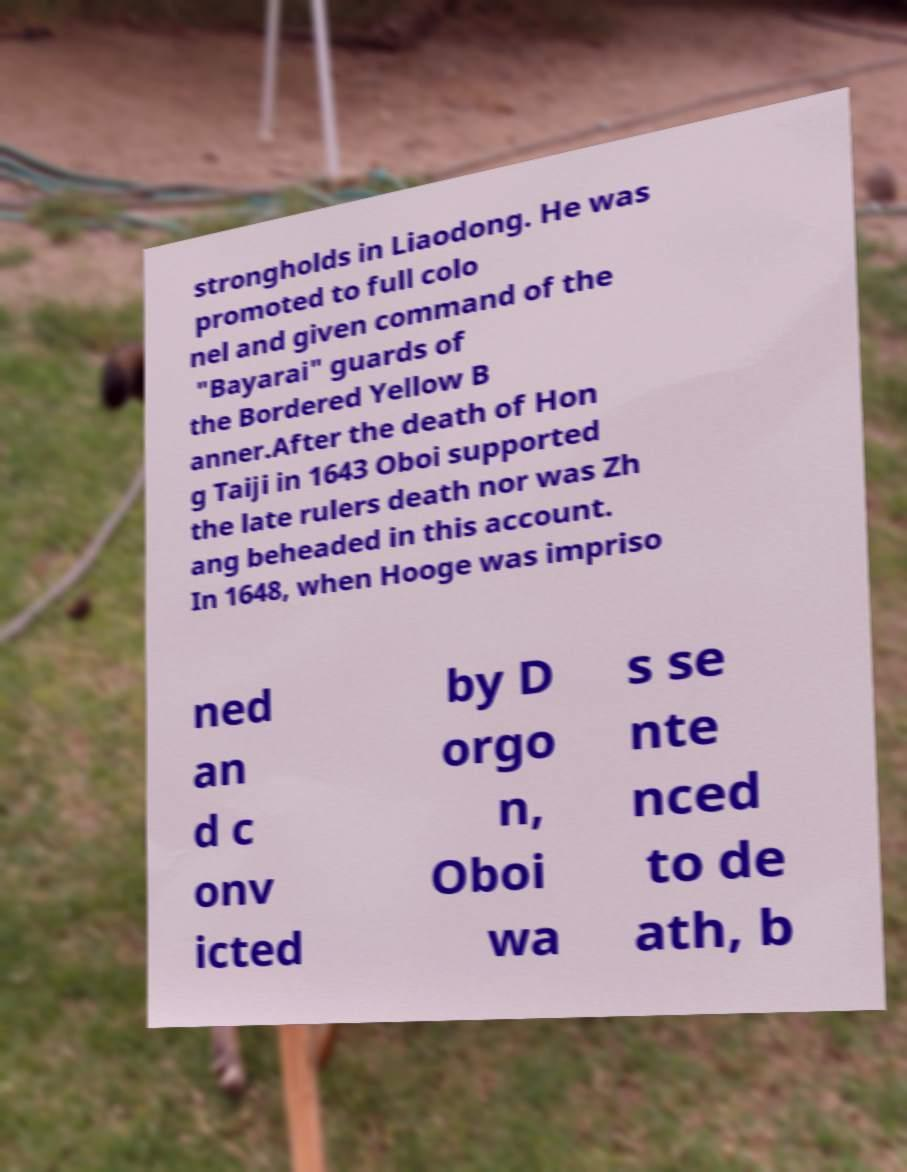Can you accurately transcribe the text from the provided image for me? strongholds in Liaodong. He was promoted to full colo nel and given command of the "Bayarai" guards of the Bordered Yellow B anner.After the death of Hon g Taiji in 1643 Oboi supported the late rulers death nor was Zh ang beheaded in this account. In 1648, when Hooge was impriso ned an d c onv icted by D orgo n, Oboi wa s se nte nced to de ath, b 